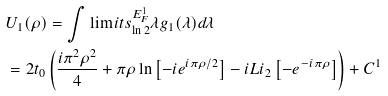Convert formula to latex. <formula><loc_0><loc_0><loc_500><loc_500>& U _ { 1 } ( \rho ) = \int \lim i t s _ { \ln 2 } ^ { E _ { F } ^ { 1 } } { \lambda g _ { 1 } ( \lambda ) d \lambda } \\ & = 2 t _ { 0 } \left ( { \frac { i \pi ^ { 2 } \rho ^ { 2 } } { 4 } + \pi \rho \ln \left [ { - i e ^ { i \pi \rho / 2 } } \right ] - i L i _ { 2 } \left [ { - e ^ { - i \pi \rho } } \right ] } \right ) + C ^ { 1 } \\</formula> 